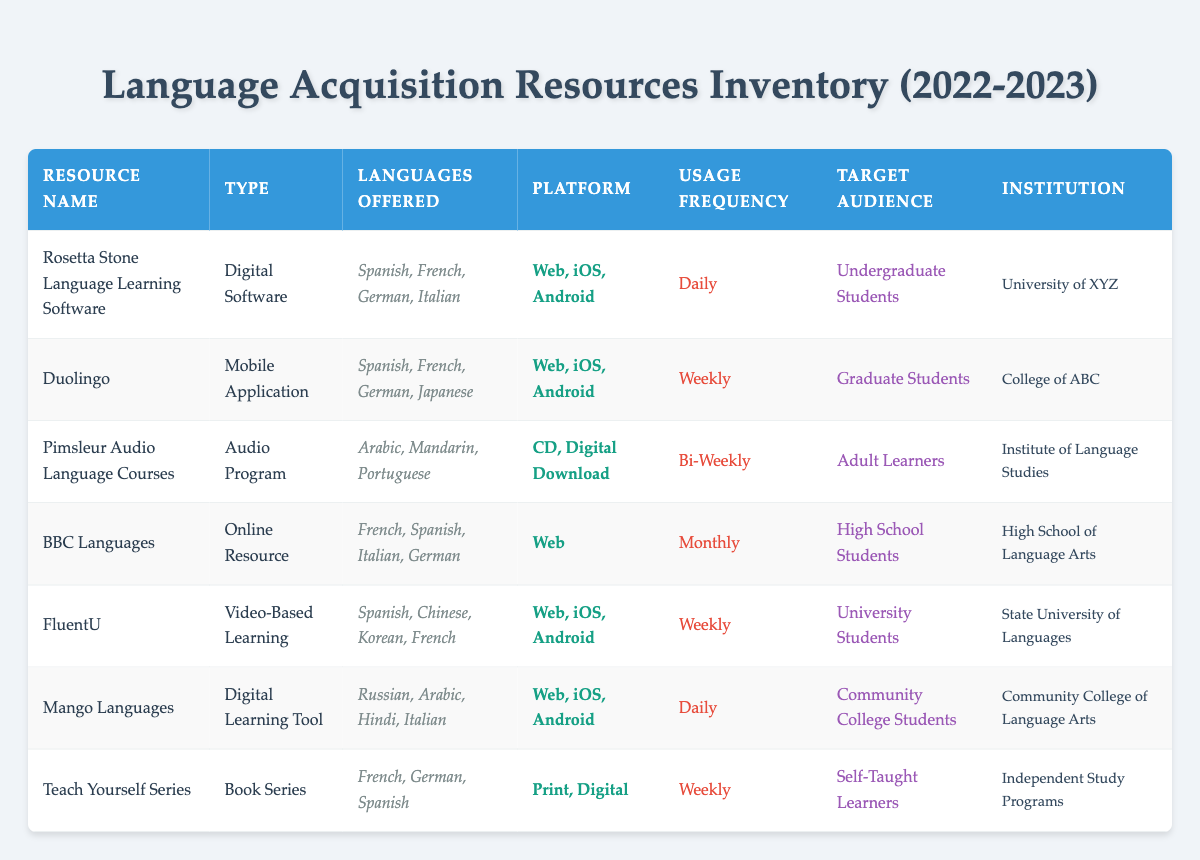What is the usage frequency of Rosetta Stone Language Learning Software? The table shows the usage frequency under the "Usage Frequency" column. Looking at the row for "Rosetta Stone Language Learning Software," it clearly states "Daily."
Answer: Daily Which institution uses FluentU? The table provides the "Institution" for each resource. For "FluentU," it is listed as "State University of Languages."
Answer: State University of Languages Is Duolingo a digital or print resource? To answer this, we can look at the "Type" column for "Duolingo." It is categorized as a "Mobile Application," indicating that it is a digital resource. Therefore, the answer is yes, it is digital.
Answer: Yes How many different languages does the Teach Yourself Series cover? The languages offered by "Teach Yourself Series" are listed in the "Languages Offered" column. It includes French, German, and Spanish, totaling three different languages covered by this resource.
Answer: 3 Are there any resources that target Community College Students? By examining the "Target Audience" column, we find that "Mango Languages" is specifically designed for "Community College Students." This confirms that there is a resource targeting this audience.
Answer: Yes What is the most frequently used language acquisition resource according to usage frequency? To determine the most frequently used resource, we look for the highest frequency in the "Usage Frequency" column. "Rosetta Stone Language Learning Software" and "Mango Languages" are both "Daily," which is the highest frequency compared to others. Hence, at least two resources can fit this criterion.
Answer: Rosetta Stone, Mango Languages How many resources are marked as monthly usage frequency? In the "Usage Frequency" column, we scan for the term "Monthly." The entry for "BBC Languages" falls under this category, so there is one resource with a monthly frequency.
Answer: 1 Which resource offers Arabic among its languages? We can look in the "Languages Offered" column for any entry that includes "Arabic." The resources "Pimsleur Audio Language Courses" and "Mango Languages" both list Arabic, confirming their availability in this language.
Answer: Pimsleur Audio Language Courses, Mango Languages What type of resource is the Teach Yourself Series? By checking the "Type" column for the "Teach Yourself Series," we see that it is classified as a "Book Series." This answer is directly available in the table.
Answer: Book Series 